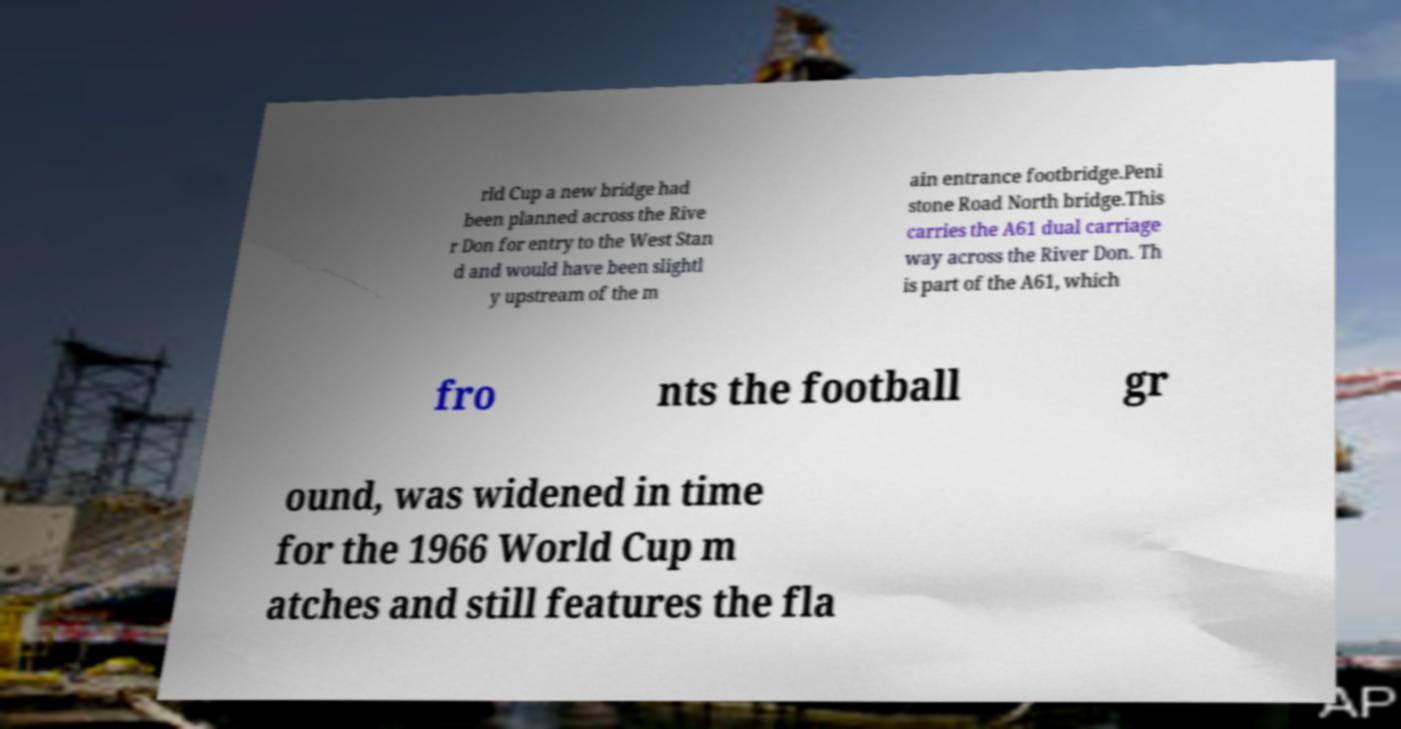There's text embedded in this image that I need extracted. Can you transcribe it verbatim? rld Cup a new bridge had been planned across the Rive r Don for entry to the West Stan d and would have been slightl y upstream of the m ain entrance footbridge.Peni stone Road North bridge.This carries the A61 dual carriage way across the River Don. Th is part of the A61, which fro nts the football gr ound, was widened in time for the 1966 World Cup m atches and still features the fla 